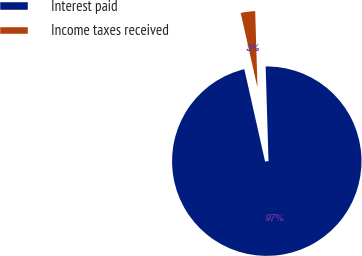Convert chart to OTSL. <chart><loc_0><loc_0><loc_500><loc_500><pie_chart><fcel>Interest paid<fcel>Income taxes received<nl><fcel>96.96%<fcel>3.04%<nl></chart> 